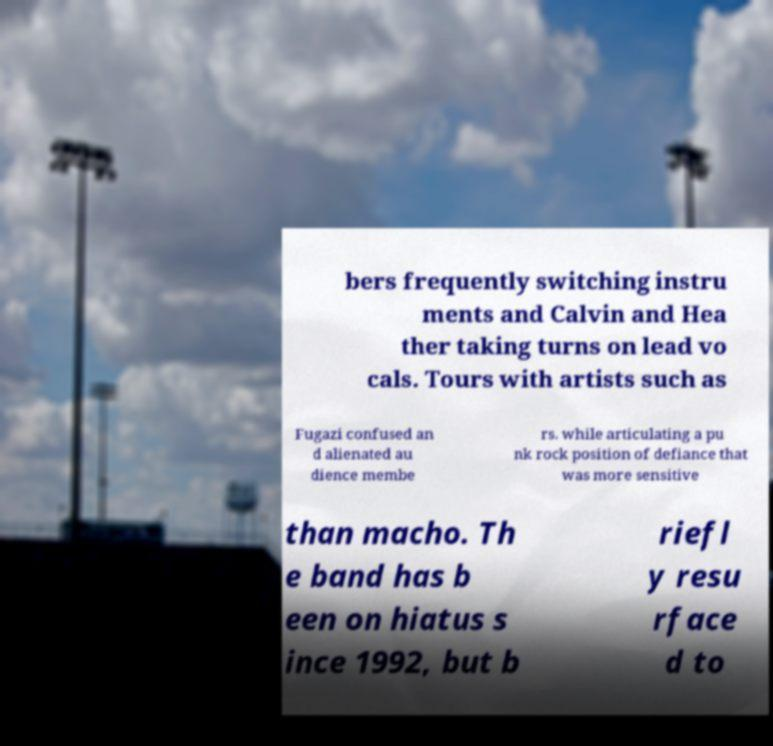Could you extract and type out the text from this image? bers frequently switching instru ments and Calvin and Hea ther taking turns on lead vo cals. Tours with artists such as Fugazi confused an d alienated au dience membe rs. while articulating a pu nk rock position of defiance that was more sensitive than macho. Th e band has b een on hiatus s ince 1992, but b riefl y resu rface d to 